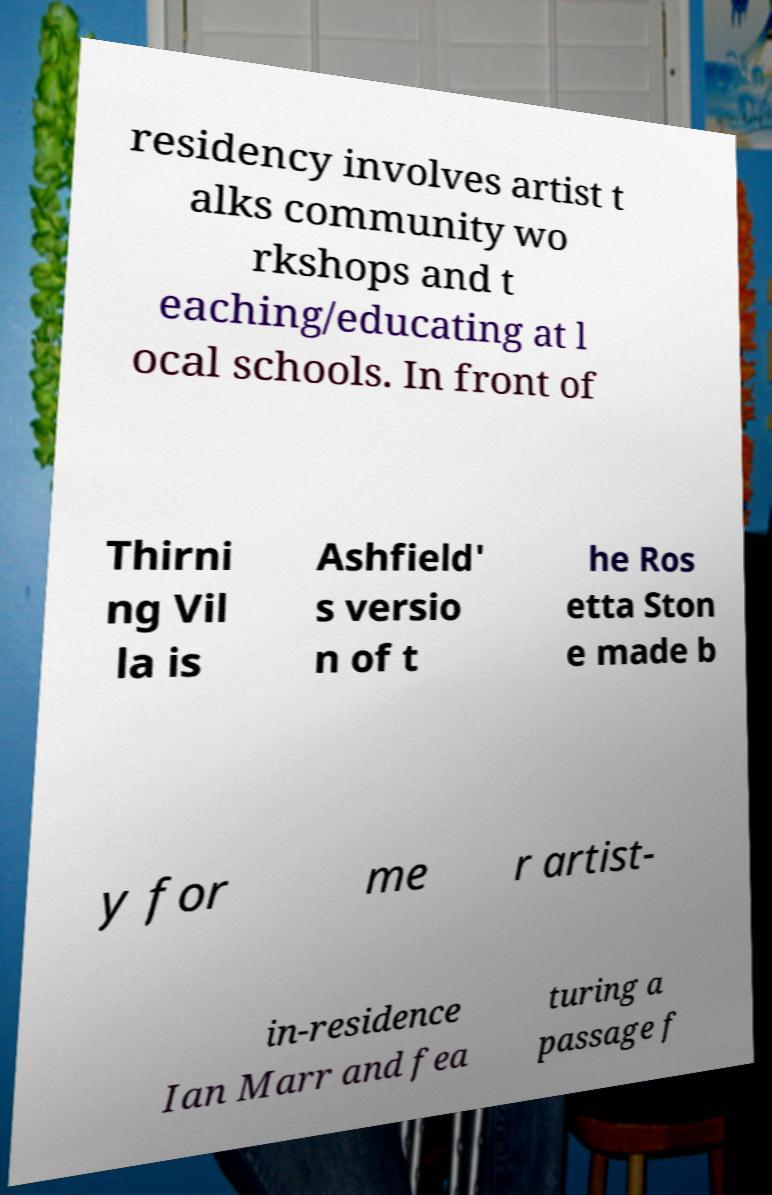Could you extract and type out the text from this image? residency involves artist t alks community wo rkshops and t eaching/educating at l ocal schools. In front of Thirni ng Vil la is Ashfield' s versio n of t he Ros etta Ston e made b y for me r artist- in-residence Ian Marr and fea turing a passage f 